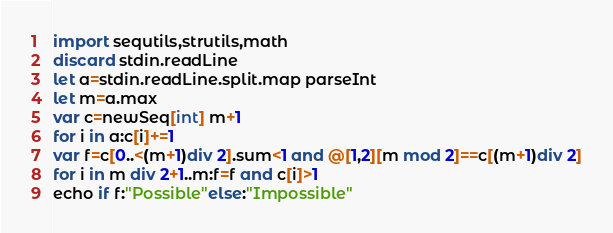Convert code to text. <code><loc_0><loc_0><loc_500><loc_500><_Nim_>import sequtils,strutils,math
discard stdin.readLine
let a=stdin.readLine.split.map parseInt
let m=a.max
var c=newSeq[int] m+1
for i in a:c[i]+=1
var f=c[0..<(m+1)div 2].sum<1 and @[1,2][m mod 2]==c[(m+1)div 2]
for i in m div 2+1..m:f=f and c[i]>1
echo if f:"Possible"else:"Impossible"</code> 